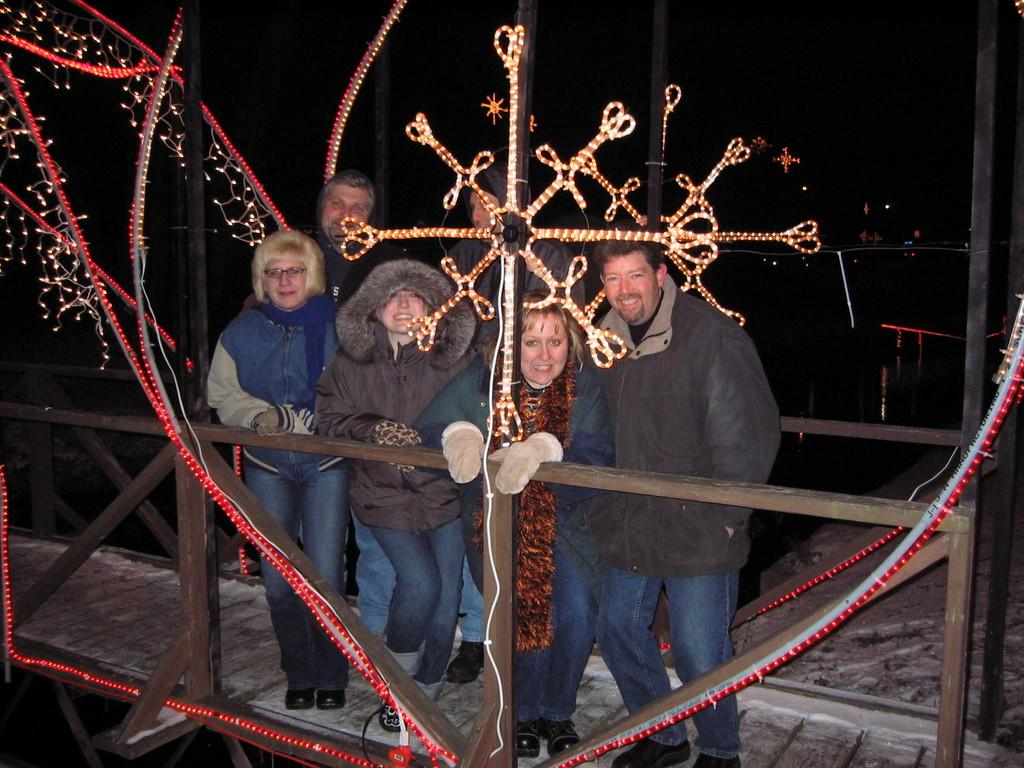What are the people in the image doing on the bridge? The people in the image are standing on a bridge. What is the facial expression of the people in the image? The people in the image are smiling. What can be seen in front of the people on the bridge? There are lights in front of the people. What is visible in the background of the image? There is water visible in the background of the image. What type of swing can be seen in the image? There is no swing present in the image. What kind of bushes are growing near the water in the image? There is no mention of bushes in the image; only water is visible in the background. 